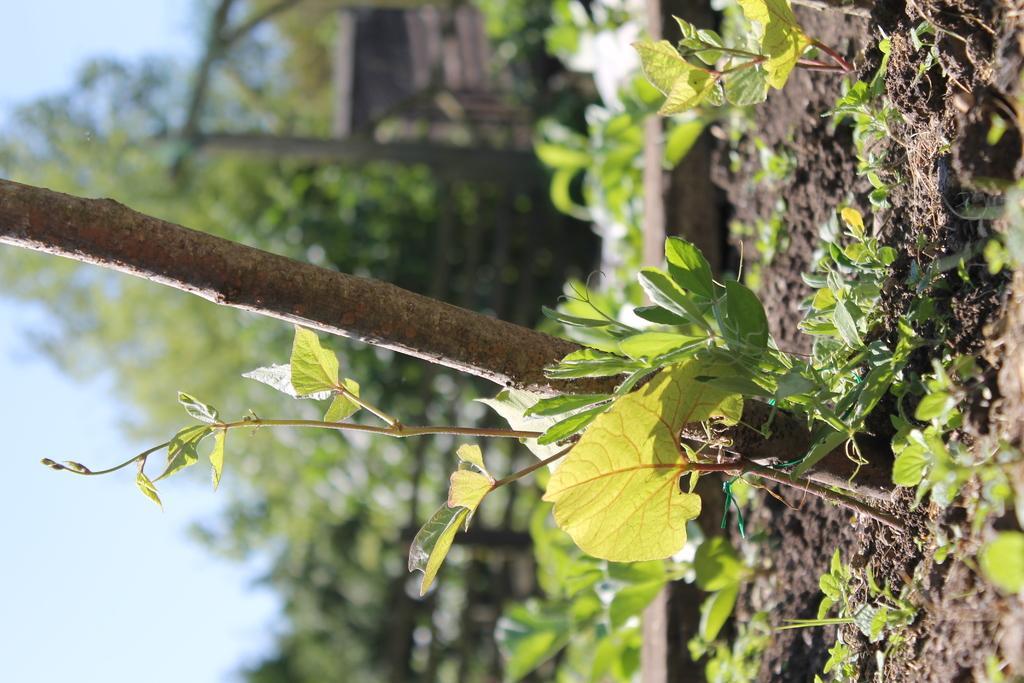Could you give a brief overview of what you see in this image? In this image we can see plants and trees. On the left side, we can see the sky. 